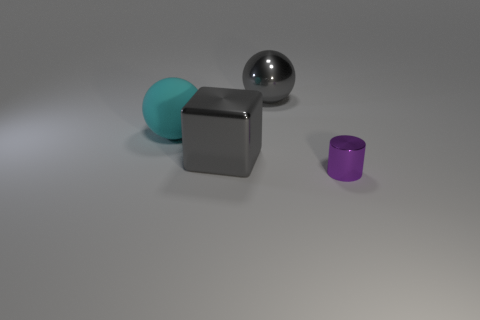Subtract all cyan spheres. How many spheres are left? 1 Add 2 green matte balls. How many objects exist? 6 Subtract all cylinders. How many objects are left? 3 Subtract all big gray metallic objects. Subtract all purple cylinders. How many objects are left? 1 Add 2 large rubber objects. How many large rubber objects are left? 3 Add 2 shiny blocks. How many shiny blocks exist? 3 Subtract 0 brown cylinders. How many objects are left? 4 Subtract all red spheres. Subtract all brown cylinders. How many spheres are left? 2 